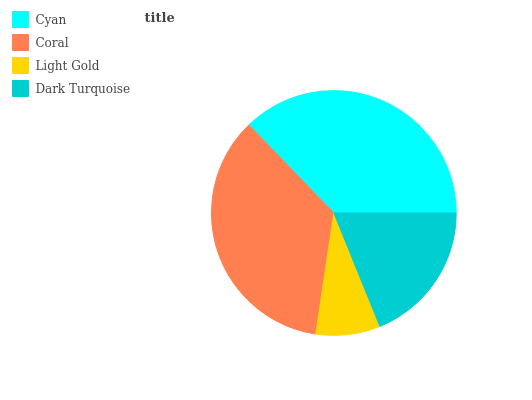Is Light Gold the minimum?
Answer yes or no. Yes. Is Cyan the maximum?
Answer yes or no. Yes. Is Coral the minimum?
Answer yes or no. No. Is Coral the maximum?
Answer yes or no. No. Is Cyan greater than Coral?
Answer yes or no. Yes. Is Coral less than Cyan?
Answer yes or no. Yes. Is Coral greater than Cyan?
Answer yes or no. No. Is Cyan less than Coral?
Answer yes or no. No. Is Coral the high median?
Answer yes or no. Yes. Is Dark Turquoise the low median?
Answer yes or no. Yes. Is Light Gold the high median?
Answer yes or no. No. Is Light Gold the low median?
Answer yes or no. No. 